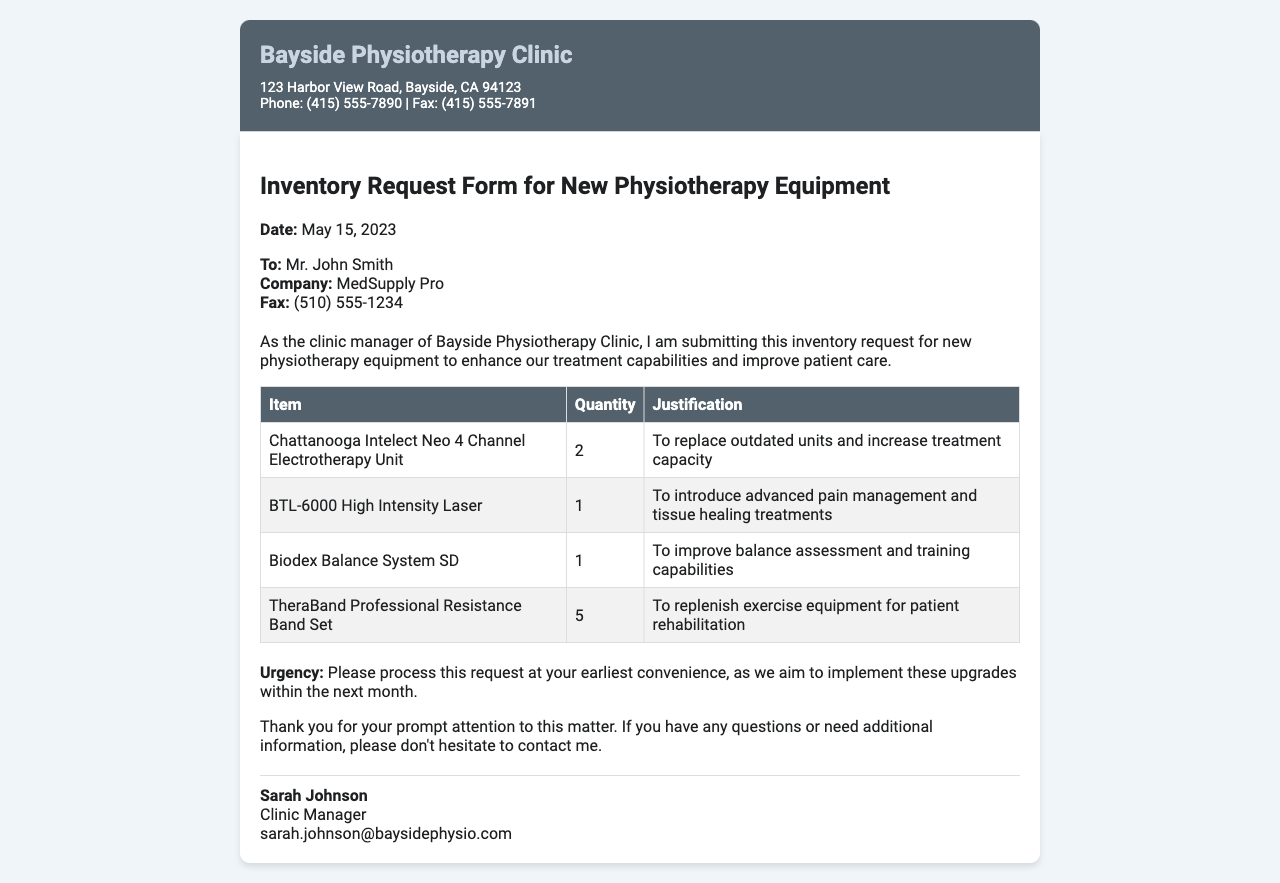What is the date of the fax? The date of the fax is listed at the top of the document.
Answer: May 15, 2023 Who is the recipient of the fax? The recipient's name is mentioned in the recipient section.
Answer: Mr. John Smith How many Chattanooga Intelect Neo 4 Channel Electrotherapy Units are requested? The requested quantity is provided in the equipment list table.
Answer: 2 What equipment is requested to improve balance assessment? The specific equipment requested is found in the justification section of the equipment list.
Answer: Biodex Balance System SD What is the urgency for processing the request? The urgency is detailed towards the end of the document.
Answer: At your earliest convenience What company is the fax directed to? The company's name is stated in the recipient section of the document.
Answer: MedSupply Pro How many TheraBand Professional Resistance Band Sets are requested? The quantity is mentioned in the equipment list under the respective item.
Answer: 5 What is the justification for requesting the BTL-6000 High Intensity Laser? The justification for the request is included in the equipment list table.
Answer: To introduce advanced pain management and tissue healing treatments Who is the sender of the fax? The sender's name is included at the end of the document.
Answer: Sarah Johnson 